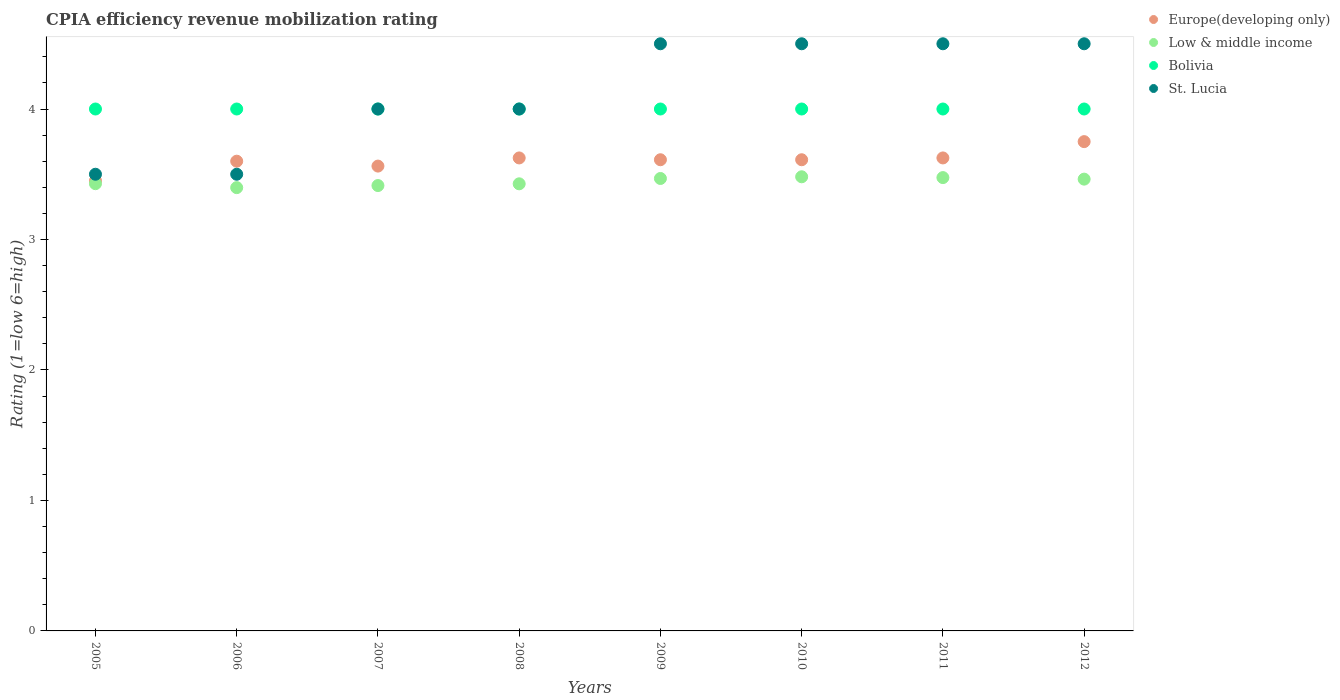Is the number of dotlines equal to the number of legend labels?
Keep it short and to the point. Yes. What is the CPIA rating in Bolivia in 2008?
Give a very brief answer. 4. Across all years, what is the minimum CPIA rating in Low & middle income?
Your response must be concise. 3.4. In which year was the CPIA rating in Bolivia maximum?
Offer a terse response. 2005. What is the total CPIA rating in St. Lucia in the graph?
Offer a terse response. 33. What is the difference between the CPIA rating in Bolivia in 2008 and the CPIA rating in Europe(developing only) in 2010?
Provide a succinct answer. 0.39. What is the average CPIA rating in Low & middle income per year?
Your answer should be very brief. 3.44. In the year 2008, what is the difference between the CPIA rating in Low & middle income and CPIA rating in St. Lucia?
Offer a very short reply. -0.57. What is the ratio of the CPIA rating in St. Lucia in 2006 to that in 2010?
Your answer should be very brief. 0.78. Is the difference between the CPIA rating in Low & middle income in 2006 and 2010 greater than the difference between the CPIA rating in St. Lucia in 2006 and 2010?
Offer a very short reply. Yes. What is the difference between the highest and the second highest CPIA rating in Europe(developing only)?
Provide a short and direct response. 0.12. What is the difference between the highest and the lowest CPIA rating in St. Lucia?
Your response must be concise. 1. In how many years, is the CPIA rating in Low & middle income greater than the average CPIA rating in Low & middle income taken over all years?
Offer a very short reply. 4. Is the sum of the CPIA rating in Europe(developing only) in 2008 and 2012 greater than the maximum CPIA rating in Bolivia across all years?
Keep it short and to the point. Yes. Is it the case that in every year, the sum of the CPIA rating in Bolivia and CPIA rating in Europe(developing only)  is greater than the sum of CPIA rating in Low & middle income and CPIA rating in St. Lucia?
Your answer should be very brief. No. How many dotlines are there?
Offer a very short reply. 4. What is the difference between two consecutive major ticks on the Y-axis?
Ensure brevity in your answer.  1. Does the graph contain any zero values?
Give a very brief answer. No. Does the graph contain grids?
Your response must be concise. No. Where does the legend appear in the graph?
Make the answer very short. Top right. What is the title of the graph?
Offer a very short reply. CPIA efficiency revenue mobilization rating. Does "Burkina Faso" appear as one of the legend labels in the graph?
Your answer should be very brief. No. What is the Rating (1=low 6=high) of Europe(developing only) in 2005?
Your answer should be very brief. 3.45. What is the Rating (1=low 6=high) in Low & middle income in 2005?
Give a very brief answer. 3.43. What is the Rating (1=low 6=high) of St. Lucia in 2005?
Your answer should be very brief. 3.5. What is the Rating (1=low 6=high) in Europe(developing only) in 2006?
Keep it short and to the point. 3.6. What is the Rating (1=low 6=high) in Low & middle income in 2006?
Keep it short and to the point. 3.4. What is the Rating (1=low 6=high) of Europe(developing only) in 2007?
Your answer should be very brief. 3.56. What is the Rating (1=low 6=high) of Low & middle income in 2007?
Give a very brief answer. 3.41. What is the Rating (1=low 6=high) in Europe(developing only) in 2008?
Your response must be concise. 3.62. What is the Rating (1=low 6=high) of Low & middle income in 2008?
Provide a short and direct response. 3.43. What is the Rating (1=low 6=high) in Bolivia in 2008?
Your answer should be compact. 4. What is the Rating (1=low 6=high) in St. Lucia in 2008?
Your answer should be very brief. 4. What is the Rating (1=low 6=high) in Europe(developing only) in 2009?
Provide a short and direct response. 3.61. What is the Rating (1=low 6=high) of Low & middle income in 2009?
Provide a succinct answer. 3.47. What is the Rating (1=low 6=high) in St. Lucia in 2009?
Give a very brief answer. 4.5. What is the Rating (1=low 6=high) in Europe(developing only) in 2010?
Offer a very short reply. 3.61. What is the Rating (1=low 6=high) of Low & middle income in 2010?
Your response must be concise. 3.48. What is the Rating (1=low 6=high) in St. Lucia in 2010?
Your answer should be compact. 4.5. What is the Rating (1=low 6=high) in Europe(developing only) in 2011?
Ensure brevity in your answer.  3.62. What is the Rating (1=low 6=high) of Low & middle income in 2011?
Keep it short and to the point. 3.47. What is the Rating (1=low 6=high) in Bolivia in 2011?
Offer a very short reply. 4. What is the Rating (1=low 6=high) in Europe(developing only) in 2012?
Give a very brief answer. 3.75. What is the Rating (1=low 6=high) in Low & middle income in 2012?
Provide a short and direct response. 3.46. What is the Rating (1=low 6=high) in St. Lucia in 2012?
Ensure brevity in your answer.  4.5. Across all years, what is the maximum Rating (1=low 6=high) in Europe(developing only)?
Keep it short and to the point. 3.75. Across all years, what is the maximum Rating (1=low 6=high) of Low & middle income?
Ensure brevity in your answer.  3.48. Across all years, what is the maximum Rating (1=low 6=high) in St. Lucia?
Your answer should be compact. 4.5. Across all years, what is the minimum Rating (1=low 6=high) in Europe(developing only)?
Offer a very short reply. 3.45. Across all years, what is the minimum Rating (1=low 6=high) in Low & middle income?
Offer a terse response. 3.4. Across all years, what is the minimum Rating (1=low 6=high) of St. Lucia?
Offer a very short reply. 3.5. What is the total Rating (1=low 6=high) in Europe(developing only) in the graph?
Keep it short and to the point. 28.83. What is the total Rating (1=low 6=high) in Low & middle income in the graph?
Keep it short and to the point. 27.55. What is the total Rating (1=low 6=high) in Bolivia in the graph?
Give a very brief answer. 32. What is the total Rating (1=low 6=high) in St. Lucia in the graph?
Provide a short and direct response. 33. What is the difference between the Rating (1=low 6=high) in Low & middle income in 2005 and that in 2006?
Your answer should be very brief. 0.03. What is the difference between the Rating (1=low 6=high) of Europe(developing only) in 2005 and that in 2007?
Ensure brevity in your answer.  -0.11. What is the difference between the Rating (1=low 6=high) of Low & middle income in 2005 and that in 2007?
Your answer should be very brief. 0.01. What is the difference between the Rating (1=low 6=high) in Bolivia in 2005 and that in 2007?
Ensure brevity in your answer.  0. What is the difference between the Rating (1=low 6=high) of Europe(developing only) in 2005 and that in 2008?
Keep it short and to the point. -0.17. What is the difference between the Rating (1=low 6=high) of Europe(developing only) in 2005 and that in 2009?
Provide a short and direct response. -0.16. What is the difference between the Rating (1=low 6=high) in Low & middle income in 2005 and that in 2009?
Your answer should be compact. -0.04. What is the difference between the Rating (1=low 6=high) in Bolivia in 2005 and that in 2009?
Your answer should be very brief. 0. What is the difference between the Rating (1=low 6=high) in Europe(developing only) in 2005 and that in 2010?
Your answer should be very brief. -0.16. What is the difference between the Rating (1=low 6=high) of Low & middle income in 2005 and that in 2010?
Keep it short and to the point. -0.05. What is the difference between the Rating (1=low 6=high) of St. Lucia in 2005 and that in 2010?
Offer a terse response. -1. What is the difference between the Rating (1=low 6=high) of Europe(developing only) in 2005 and that in 2011?
Your answer should be compact. -0.17. What is the difference between the Rating (1=low 6=high) of Low & middle income in 2005 and that in 2011?
Your answer should be very brief. -0.05. What is the difference between the Rating (1=low 6=high) in Bolivia in 2005 and that in 2011?
Your response must be concise. 0. What is the difference between the Rating (1=low 6=high) of Europe(developing only) in 2005 and that in 2012?
Offer a terse response. -0.3. What is the difference between the Rating (1=low 6=high) of Low & middle income in 2005 and that in 2012?
Your response must be concise. -0.03. What is the difference between the Rating (1=low 6=high) of St. Lucia in 2005 and that in 2012?
Give a very brief answer. -1. What is the difference between the Rating (1=low 6=high) of Europe(developing only) in 2006 and that in 2007?
Give a very brief answer. 0.04. What is the difference between the Rating (1=low 6=high) of Low & middle income in 2006 and that in 2007?
Your answer should be very brief. -0.02. What is the difference between the Rating (1=low 6=high) in Bolivia in 2006 and that in 2007?
Offer a terse response. 0. What is the difference between the Rating (1=low 6=high) of Europe(developing only) in 2006 and that in 2008?
Make the answer very short. -0.03. What is the difference between the Rating (1=low 6=high) in Low & middle income in 2006 and that in 2008?
Your answer should be very brief. -0.03. What is the difference between the Rating (1=low 6=high) in Bolivia in 2006 and that in 2008?
Keep it short and to the point. 0. What is the difference between the Rating (1=low 6=high) of St. Lucia in 2006 and that in 2008?
Provide a short and direct response. -0.5. What is the difference between the Rating (1=low 6=high) in Europe(developing only) in 2006 and that in 2009?
Your answer should be very brief. -0.01. What is the difference between the Rating (1=low 6=high) of Low & middle income in 2006 and that in 2009?
Make the answer very short. -0.07. What is the difference between the Rating (1=low 6=high) of St. Lucia in 2006 and that in 2009?
Make the answer very short. -1. What is the difference between the Rating (1=low 6=high) of Europe(developing only) in 2006 and that in 2010?
Your response must be concise. -0.01. What is the difference between the Rating (1=low 6=high) of Low & middle income in 2006 and that in 2010?
Provide a succinct answer. -0.08. What is the difference between the Rating (1=low 6=high) of Europe(developing only) in 2006 and that in 2011?
Provide a short and direct response. -0.03. What is the difference between the Rating (1=low 6=high) in Low & middle income in 2006 and that in 2011?
Provide a short and direct response. -0.08. What is the difference between the Rating (1=low 6=high) in St. Lucia in 2006 and that in 2011?
Ensure brevity in your answer.  -1. What is the difference between the Rating (1=low 6=high) of Europe(developing only) in 2006 and that in 2012?
Your response must be concise. -0.15. What is the difference between the Rating (1=low 6=high) in Low & middle income in 2006 and that in 2012?
Your response must be concise. -0.07. What is the difference between the Rating (1=low 6=high) in Bolivia in 2006 and that in 2012?
Your answer should be compact. 0. What is the difference between the Rating (1=low 6=high) in St. Lucia in 2006 and that in 2012?
Your answer should be compact. -1. What is the difference between the Rating (1=low 6=high) of Europe(developing only) in 2007 and that in 2008?
Provide a short and direct response. -0.06. What is the difference between the Rating (1=low 6=high) of Low & middle income in 2007 and that in 2008?
Provide a succinct answer. -0.01. What is the difference between the Rating (1=low 6=high) in Bolivia in 2007 and that in 2008?
Give a very brief answer. 0. What is the difference between the Rating (1=low 6=high) of Europe(developing only) in 2007 and that in 2009?
Provide a succinct answer. -0.05. What is the difference between the Rating (1=low 6=high) of Low & middle income in 2007 and that in 2009?
Offer a terse response. -0.05. What is the difference between the Rating (1=low 6=high) in Bolivia in 2007 and that in 2009?
Offer a very short reply. 0. What is the difference between the Rating (1=low 6=high) of St. Lucia in 2007 and that in 2009?
Give a very brief answer. -0.5. What is the difference between the Rating (1=low 6=high) of Europe(developing only) in 2007 and that in 2010?
Keep it short and to the point. -0.05. What is the difference between the Rating (1=low 6=high) in Low & middle income in 2007 and that in 2010?
Your answer should be very brief. -0.07. What is the difference between the Rating (1=low 6=high) in St. Lucia in 2007 and that in 2010?
Make the answer very short. -0.5. What is the difference between the Rating (1=low 6=high) in Europe(developing only) in 2007 and that in 2011?
Ensure brevity in your answer.  -0.06. What is the difference between the Rating (1=low 6=high) in Low & middle income in 2007 and that in 2011?
Your answer should be compact. -0.06. What is the difference between the Rating (1=low 6=high) in Bolivia in 2007 and that in 2011?
Your answer should be compact. 0. What is the difference between the Rating (1=low 6=high) of St. Lucia in 2007 and that in 2011?
Make the answer very short. -0.5. What is the difference between the Rating (1=low 6=high) of Europe(developing only) in 2007 and that in 2012?
Provide a succinct answer. -0.19. What is the difference between the Rating (1=low 6=high) in Low & middle income in 2007 and that in 2012?
Make the answer very short. -0.05. What is the difference between the Rating (1=low 6=high) of St. Lucia in 2007 and that in 2012?
Your response must be concise. -0.5. What is the difference between the Rating (1=low 6=high) of Europe(developing only) in 2008 and that in 2009?
Make the answer very short. 0.01. What is the difference between the Rating (1=low 6=high) in Low & middle income in 2008 and that in 2009?
Offer a very short reply. -0.04. What is the difference between the Rating (1=low 6=high) in Bolivia in 2008 and that in 2009?
Offer a very short reply. 0. What is the difference between the Rating (1=low 6=high) in Europe(developing only) in 2008 and that in 2010?
Give a very brief answer. 0.01. What is the difference between the Rating (1=low 6=high) in Low & middle income in 2008 and that in 2010?
Make the answer very short. -0.05. What is the difference between the Rating (1=low 6=high) in St. Lucia in 2008 and that in 2010?
Your response must be concise. -0.5. What is the difference between the Rating (1=low 6=high) in Low & middle income in 2008 and that in 2011?
Your answer should be compact. -0.05. What is the difference between the Rating (1=low 6=high) in Bolivia in 2008 and that in 2011?
Offer a terse response. 0. What is the difference between the Rating (1=low 6=high) in St. Lucia in 2008 and that in 2011?
Offer a terse response. -0.5. What is the difference between the Rating (1=low 6=high) in Europe(developing only) in 2008 and that in 2012?
Your answer should be very brief. -0.12. What is the difference between the Rating (1=low 6=high) in Low & middle income in 2008 and that in 2012?
Keep it short and to the point. -0.04. What is the difference between the Rating (1=low 6=high) of Low & middle income in 2009 and that in 2010?
Give a very brief answer. -0.01. What is the difference between the Rating (1=low 6=high) in Europe(developing only) in 2009 and that in 2011?
Provide a succinct answer. -0.01. What is the difference between the Rating (1=low 6=high) in Low & middle income in 2009 and that in 2011?
Provide a short and direct response. -0.01. What is the difference between the Rating (1=low 6=high) of St. Lucia in 2009 and that in 2011?
Ensure brevity in your answer.  0. What is the difference between the Rating (1=low 6=high) in Europe(developing only) in 2009 and that in 2012?
Your response must be concise. -0.14. What is the difference between the Rating (1=low 6=high) of Low & middle income in 2009 and that in 2012?
Keep it short and to the point. 0.01. What is the difference between the Rating (1=low 6=high) in Bolivia in 2009 and that in 2012?
Keep it short and to the point. 0. What is the difference between the Rating (1=low 6=high) in Europe(developing only) in 2010 and that in 2011?
Keep it short and to the point. -0.01. What is the difference between the Rating (1=low 6=high) in Low & middle income in 2010 and that in 2011?
Make the answer very short. 0.01. What is the difference between the Rating (1=low 6=high) in Bolivia in 2010 and that in 2011?
Your answer should be compact. 0. What is the difference between the Rating (1=low 6=high) of St. Lucia in 2010 and that in 2011?
Your response must be concise. 0. What is the difference between the Rating (1=low 6=high) of Europe(developing only) in 2010 and that in 2012?
Provide a short and direct response. -0.14. What is the difference between the Rating (1=low 6=high) in Low & middle income in 2010 and that in 2012?
Provide a short and direct response. 0.02. What is the difference between the Rating (1=low 6=high) of St. Lucia in 2010 and that in 2012?
Ensure brevity in your answer.  0. What is the difference between the Rating (1=low 6=high) in Europe(developing only) in 2011 and that in 2012?
Ensure brevity in your answer.  -0.12. What is the difference between the Rating (1=low 6=high) of Low & middle income in 2011 and that in 2012?
Your answer should be compact. 0.01. What is the difference between the Rating (1=low 6=high) of Bolivia in 2011 and that in 2012?
Keep it short and to the point. 0. What is the difference between the Rating (1=low 6=high) of St. Lucia in 2011 and that in 2012?
Offer a very short reply. 0. What is the difference between the Rating (1=low 6=high) in Europe(developing only) in 2005 and the Rating (1=low 6=high) in Low & middle income in 2006?
Your answer should be very brief. 0.05. What is the difference between the Rating (1=low 6=high) in Europe(developing only) in 2005 and the Rating (1=low 6=high) in Bolivia in 2006?
Provide a succinct answer. -0.55. What is the difference between the Rating (1=low 6=high) of Low & middle income in 2005 and the Rating (1=low 6=high) of Bolivia in 2006?
Keep it short and to the point. -0.57. What is the difference between the Rating (1=low 6=high) of Low & middle income in 2005 and the Rating (1=low 6=high) of St. Lucia in 2006?
Your answer should be compact. -0.07. What is the difference between the Rating (1=low 6=high) of Europe(developing only) in 2005 and the Rating (1=low 6=high) of Low & middle income in 2007?
Ensure brevity in your answer.  0.04. What is the difference between the Rating (1=low 6=high) in Europe(developing only) in 2005 and the Rating (1=low 6=high) in Bolivia in 2007?
Your answer should be very brief. -0.55. What is the difference between the Rating (1=low 6=high) in Europe(developing only) in 2005 and the Rating (1=low 6=high) in St. Lucia in 2007?
Your answer should be very brief. -0.55. What is the difference between the Rating (1=low 6=high) of Low & middle income in 2005 and the Rating (1=low 6=high) of Bolivia in 2007?
Give a very brief answer. -0.57. What is the difference between the Rating (1=low 6=high) in Low & middle income in 2005 and the Rating (1=low 6=high) in St. Lucia in 2007?
Offer a terse response. -0.57. What is the difference between the Rating (1=low 6=high) in Europe(developing only) in 2005 and the Rating (1=low 6=high) in Low & middle income in 2008?
Keep it short and to the point. 0.02. What is the difference between the Rating (1=low 6=high) of Europe(developing only) in 2005 and the Rating (1=low 6=high) of Bolivia in 2008?
Make the answer very short. -0.55. What is the difference between the Rating (1=low 6=high) in Europe(developing only) in 2005 and the Rating (1=low 6=high) in St. Lucia in 2008?
Give a very brief answer. -0.55. What is the difference between the Rating (1=low 6=high) of Low & middle income in 2005 and the Rating (1=low 6=high) of Bolivia in 2008?
Ensure brevity in your answer.  -0.57. What is the difference between the Rating (1=low 6=high) of Low & middle income in 2005 and the Rating (1=low 6=high) of St. Lucia in 2008?
Keep it short and to the point. -0.57. What is the difference between the Rating (1=low 6=high) in Bolivia in 2005 and the Rating (1=low 6=high) in St. Lucia in 2008?
Your answer should be very brief. 0. What is the difference between the Rating (1=low 6=high) of Europe(developing only) in 2005 and the Rating (1=low 6=high) of Low & middle income in 2009?
Give a very brief answer. -0.02. What is the difference between the Rating (1=low 6=high) of Europe(developing only) in 2005 and the Rating (1=low 6=high) of Bolivia in 2009?
Provide a succinct answer. -0.55. What is the difference between the Rating (1=low 6=high) of Europe(developing only) in 2005 and the Rating (1=low 6=high) of St. Lucia in 2009?
Provide a short and direct response. -1.05. What is the difference between the Rating (1=low 6=high) in Low & middle income in 2005 and the Rating (1=low 6=high) in Bolivia in 2009?
Offer a very short reply. -0.57. What is the difference between the Rating (1=low 6=high) of Low & middle income in 2005 and the Rating (1=low 6=high) of St. Lucia in 2009?
Give a very brief answer. -1.07. What is the difference between the Rating (1=low 6=high) in Bolivia in 2005 and the Rating (1=low 6=high) in St. Lucia in 2009?
Offer a terse response. -0.5. What is the difference between the Rating (1=low 6=high) in Europe(developing only) in 2005 and the Rating (1=low 6=high) in Low & middle income in 2010?
Make the answer very short. -0.03. What is the difference between the Rating (1=low 6=high) in Europe(developing only) in 2005 and the Rating (1=low 6=high) in Bolivia in 2010?
Provide a short and direct response. -0.55. What is the difference between the Rating (1=low 6=high) in Europe(developing only) in 2005 and the Rating (1=low 6=high) in St. Lucia in 2010?
Provide a succinct answer. -1.05. What is the difference between the Rating (1=low 6=high) in Low & middle income in 2005 and the Rating (1=low 6=high) in Bolivia in 2010?
Give a very brief answer. -0.57. What is the difference between the Rating (1=low 6=high) in Low & middle income in 2005 and the Rating (1=low 6=high) in St. Lucia in 2010?
Keep it short and to the point. -1.07. What is the difference between the Rating (1=low 6=high) of Europe(developing only) in 2005 and the Rating (1=low 6=high) of Low & middle income in 2011?
Offer a terse response. -0.02. What is the difference between the Rating (1=low 6=high) in Europe(developing only) in 2005 and the Rating (1=low 6=high) in Bolivia in 2011?
Offer a terse response. -0.55. What is the difference between the Rating (1=low 6=high) in Europe(developing only) in 2005 and the Rating (1=low 6=high) in St. Lucia in 2011?
Provide a short and direct response. -1.05. What is the difference between the Rating (1=low 6=high) of Low & middle income in 2005 and the Rating (1=low 6=high) of Bolivia in 2011?
Provide a succinct answer. -0.57. What is the difference between the Rating (1=low 6=high) in Low & middle income in 2005 and the Rating (1=low 6=high) in St. Lucia in 2011?
Provide a short and direct response. -1.07. What is the difference between the Rating (1=low 6=high) of Bolivia in 2005 and the Rating (1=low 6=high) of St. Lucia in 2011?
Give a very brief answer. -0.5. What is the difference between the Rating (1=low 6=high) in Europe(developing only) in 2005 and the Rating (1=low 6=high) in Low & middle income in 2012?
Provide a short and direct response. -0.01. What is the difference between the Rating (1=low 6=high) in Europe(developing only) in 2005 and the Rating (1=low 6=high) in Bolivia in 2012?
Your answer should be compact. -0.55. What is the difference between the Rating (1=low 6=high) of Europe(developing only) in 2005 and the Rating (1=low 6=high) of St. Lucia in 2012?
Your response must be concise. -1.05. What is the difference between the Rating (1=low 6=high) in Low & middle income in 2005 and the Rating (1=low 6=high) in Bolivia in 2012?
Make the answer very short. -0.57. What is the difference between the Rating (1=low 6=high) of Low & middle income in 2005 and the Rating (1=low 6=high) of St. Lucia in 2012?
Keep it short and to the point. -1.07. What is the difference between the Rating (1=low 6=high) in Bolivia in 2005 and the Rating (1=low 6=high) in St. Lucia in 2012?
Keep it short and to the point. -0.5. What is the difference between the Rating (1=low 6=high) of Europe(developing only) in 2006 and the Rating (1=low 6=high) of Low & middle income in 2007?
Ensure brevity in your answer.  0.19. What is the difference between the Rating (1=low 6=high) in Europe(developing only) in 2006 and the Rating (1=low 6=high) in Bolivia in 2007?
Offer a terse response. -0.4. What is the difference between the Rating (1=low 6=high) of Europe(developing only) in 2006 and the Rating (1=low 6=high) of St. Lucia in 2007?
Your answer should be very brief. -0.4. What is the difference between the Rating (1=low 6=high) in Low & middle income in 2006 and the Rating (1=low 6=high) in Bolivia in 2007?
Make the answer very short. -0.6. What is the difference between the Rating (1=low 6=high) in Low & middle income in 2006 and the Rating (1=low 6=high) in St. Lucia in 2007?
Provide a succinct answer. -0.6. What is the difference between the Rating (1=low 6=high) of Europe(developing only) in 2006 and the Rating (1=low 6=high) of Low & middle income in 2008?
Your answer should be compact. 0.17. What is the difference between the Rating (1=low 6=high) in Europe(developing only) in 2006 and the Rating (1=low 6=high) in Bolivia in 2008?
Make the answer very short. -0.4. What is the difference between the Rating (1=low 6=high) in Europe(developing only) in 2006 and the Rating (1=low 6=high) in St. Lucia in 2008?
Your answer should be compact. -0.4. What is the difference between the Rating (1=low 6=high) of Low & middle income in 2006 and the Rating (1=low 6=high) of Bolivia in 2008?
Your response must be concise. -0.6. What is the difference between the Rating (1=low 6=high) of Low & middle income in 2006 and the Rating (1=low 6=high) of St. Lucia in 2008?
Make the answer very short. -0.6. What is the difference between the Rating (1=low 6=high) in Bolivia in 2006 and the Rating (1=low 6=high) in St. Lucia in 2008?
Your answer should be very brief. 0. What is the difference between the Rating (1=low 6=high) of Europe(developing only) in 2006 and the Rating (1=low 6=high) of Low & middle income in 2009?
Offer a very short reply. 0.13. What is the difference between the Rating (1=low 6=high) of Europe(developing only) in 2006 and the Rating (1=low 6=high) of Bolivia in 2009?
Keep it short and to the point. -0.4. What is the difference between the Rating (1=low 6=high) of Europe(developing only) in 2006 and the Rating (1=low 6=high) of St. Lucia in 2009?
Your response must be concise. -0.9. What is the difference between the Rating (1=low 6=high) of Low & middle income in 2006 and the Rating (1=low 6=high) of Bolivia in 2009?
Offer a very short reply. -0.6. What is the difference between the Rating (1=low 6=high) of Low & middle income in 2006 and the Rating (1=low 6=high) of St. Lucia in 2009?
Offer a very short reply. -1.1. What is the difference between the Rating (1=low 6=high) of Bolivia in 2006 and the Rating (1=low 6=high) of St. Lucia in 2009?
Give a very brief answer. -0.5. What is the difference between the Rating (1=low 6=high) in Europe(developing only) in 2006 and the Rating (1=low 6=high) in Low & middle income in 2010?
Ensure brevity in your answer.  0.12. What is the difference between the Rating (1=low 6=high) of Europe(developing only) in 2006 and the Rating (1=low 6=high) of Bolivia in 2010?
Offer a very short reply. -0.4. What is the difference between the Rating (1=low 6=high) in Europe(developing only) in 2006 and the Rating (1=low 6=high) in St. Lucia in 2010?
Provide a succinct answer. -0.9. What is the difference between the Rating (1=low 6=high) of Low & middle income in 2006 and the Rating (1=low 6=high) of Bolivia in 2010?
Your answer should be very brief. -0.6. What is the difference between the Rating (1=low 6=high) of Low & middle income in 2006 and the Rating (1=low 6=high) of St. Lucia in 2010?
Offer a very short reply. -1.1. What is the difference between the Rating (1=low 6=high) in Europe(developing only) in 2006 and the Rating (1=low 6=high) in Low & middle income in 2011?
Your answer should be very brief. 0.13. What is the difference between the Rating (1=low 6=high) of Europe(developing only) in 2006 and the Rating (1=low 6=high) of Bolivia in 2011?
Your response must be concise. -0.4. What is the difference between the Rating (1=low 6=high) of Europe(developing only) in 2006 and the Rating (1=low 6=high) of St. Lucia in 2011?
Your answer should be very brief. -0.9. What is the difference between the Rating (1=low 6=high) of Low & middle income in 2006 and the Rating (1=low 6=high) of Bolivia in 2011?
Provide a short and direct response. -0.6. What is the difference between the Rating (1=low 6=high) in Low & middle income in 2006 and the Rating (1=low 6=high) in St. Lucia in 2011?
Provide a short and direct response. -1.1. What is the difference between the Rating (1=low 6=high) of Europe(developing only) in 2006 and the Rating (1=low 6=high) of Low & middle income in 2012?
Your answer should be compact. 0.14. What is the difference between the Rating (1=low 6=high) in Low & middle income in 2006 and the Rating (1=low 6=high) in Bolivia in 2012?
Your answer should be very brief. -0.6. What is the difference between the Rating (1=low 6=high) of Low & middle income in 2006 and the Rating (1=low 6=high) of St. Lucia in 2012?
Your answer should be very brief. -1.1. What is the difference between the Rating (1=low 6=high) in Bolivia in 2006 and the Rating (1=low 6=high) in St. Lucia in 2012?
Give a very brief answer. -0.5. What is the difference between the Rating (1=low 6=high) in Europe(developing only) in 2007 and the Rating (1=low 6=high) in Low & middle income in 2008?
Offer a very short reply. 0.14. What is the difference between the Rating (1=low 6=high) of Europe(developing only) in 2007 and the Rating (1=low 6=high) of Bolivia in 2008?
Ensure brevity in your answer.  -0.44. What is the difference between the Rating (1=low 6=high) in Europe(developing only) in 2007 and the Rating (1=low 6=high) in St. Lucia in 2008?
Provide a succinct answer. -0.44. What is the difference between the Rating (1=low 6=high) in Low & middle income in 2007 and the Rating (1=low 6=high) in Bolivia in 2008?
Offer a terse response. -0.59. What is the difference between the Rating (1=low 6=high) of Low & middle income in 2007 and the Rating (1=low 6=high) of St. Lucia in 2008?
Give a very brief answer. -0.59. What is the difference between the Rating (1=low 6=high) in Bolivia in 2007 and the Rating (1=low 6=high) in St. Lucia in 2008?
Offer a very short reply. 0. What is the difference between the Rating (1=low 6=high) of Europe(developing only) in 2007 and the Rating (1=low 6=high) of Low & middle income in 2009?
Provide a short and direct response. 0.1. What is the difference between the Rating (1=low 6=high) of Europe(developing only) in 2007 and the Rating (1=low 6=high) of Bolivia in 2009?
Make the answer very short. -0.44. What is the difference between the Rating (1=low 6=high) of Europe(developing only) in 2007 and the Rating (1=low 6=high) of St. Lucia in 2009?
Give a very brief answer. -0.94. What is the difference between the Rating (1=low 6=high) of Low & middle income in 2007 and the Rating (1=low 6=high) of Bolivia in 2009?
Provide a short and direct response. -0.59. What is the difference between the Rating (1=low 6=high) of Low & middle income in 2007 and the Rating (1=low 6=high) of St. Lucia in 2009?
Provide a succinct answer. -1.09. What is the difference between the Rating (1=low 6=high) in Bolivia in 2007 and the Rating (1=low 6=high) in St. Lucia in 2009?
Give a very brief answer. -0.5. What is the difference between the Rating (1=low 6=high) of Europe(developing only) in 2007 and the Rating (1=low 6=high) of Low & middle income in 2010?
Ensure brevity in your answer.  0.08. What is the difference between the Rating (1=low 6=high) in Europe(developing only) in 2007 and the Rating (1=low 6=high) in Bolivia in 2010?
Offer a terse response. -0.44. What is the difference between the Rating (1=low 6=high) in Europe(developing only) in 2007 and the Rating (1=low 6=high) in St. Lucia in 2010?
Your answer should be compact. -0.94. What is the difference between the Rating (1=low 6=high) of Low & middle income in 2007 and the Rating (1=low 6=high) of Bolivia in 2010?
Your response must be concise. -0.59. What is the difference between the Rating (1=low 6=high) of Low & middle income in 2007 and the Rating (1=low 6=high) of St. Lucia in 2010?
Your answer should be compact. -1.09. What is the difference between the Rating (1=low 6=high) of Europe(developing only) in 2007 and the Rating (1=low 6=high) of Low & middle income in 2011?
Your answer should be compact. 0.09. What is the difference between the Rating (1=low 6=high) of Europe(developing only) in 2007 and the Rating (1=low 6=high) of Bolivia in 2011?
Provide a succinct answer. -0.44. What is the difference between the Rating (1=low 6=high) of Europe(developing only) in 2007 and the Rating (1=low 6=high) of St. Lucia in 2011?
Provide a short and direct response. -0.94. What is the difference between the Rating (1=low 6=high) in Low & middle income in 2007 and the Rating (1=low 6=high) in Bolivia in 2011?
Ensure brevity in your answer.  -0.59. What is the difference between the Rating (1=low 6=high) in Low & middle income in 2007 and the Rating (1=low 6=high) in St. Lucia in 2011?
Keep it short and to the point. -1.09. What is the difference between the Rating (1=low 6=high) of Europe(developing only) in 2007 and the Rating (1=low 6=high) of Low & middle income in 2012?
Keep it short and to the point. 0.1. What is the difference between the Rating (1=low 6=high) of Europe(developing only) in 2007 and the Rating (1=low 6=high) of Bolivia in 2012?
Give a very brief answer. -0.44. What is the difference between the Rating (1=low 6=high) of Europe(developing only) in 2007 and the Rating (1=low 6=high) of St. Lucia in 2012?
Offer a very short reply. -0.94. What is the difference between the Rating (1=low 6=high) of Low & middle income in 2007 and the Rating (1=low 6=high) of Bolivia in 2012?
Your response must be concise. -0.59. What is the difference between the Rating (1=low 6=high) in Low & middle income in 2007 and the Rating (1=low 6=high) in St. Lucia in 2012?
Your answer should be compact. -1.09. What is the difference between the Rating (1=low 6=high) of Bolivia in 2007 and the Rating (1=low 6=high) of St. Lucia in 2012?
Your answer should be very brief. -0.5. What is the difference between the Rating (1=low 6=high) in Europe(developing only) in 2008 and the Rating (1=low 6=high) in Low & middle income in 2009?
Your response must be concise. 0.16. What is the difference between the Rating (1=low 6=high) in Europe(developing only) in 2008 and the Rating (1=low 6=high) in Bolivia in 2009?
Provide a succinct answer. -0.38. What is the difference between the Rating (1=low 6=high) in Europe(developing only) in 2008 and the Rating (1=low 6=high) in St. Lucia in 2009?
Ensure brevity in your answer.  -0.88. What is the difference between the Rating (1=low 6=high) in Low & middle income in 2008 and the Rating (1=low 6=high) in Bolivia in 2009?
Your response must be concise. -0.57. What is the difference between the Rating (1=low 6=high) in Low & middle income in 2008 and the Rating (1=low 6=high) in St. Lucia in 2009?
Give a very brief answer. -1.07. What is the difference between the Rating (1=low 6=high) in Bolivia in 2008 and the Rating (1=low 6=high) in St. Lucia in 2009?
Ensure brevity in your answer.  -0.5. What is the difference between the Rating (1=low 6=high) of Europe(developing only) in 2008 and the Rating (1=low 6=high) of Low & middle income in 2010?
Your response must be concise. 0.14. What is the difference between the Rating (1=low 6=high) of Europe(developing only) in 2008 and the Rating (1=low 6=high) of Bolivia in 2010?
Provide a succinct answer. -0.38. What is the difference between the Rating (1=low 6=high) in Europe(developing only) in 2008 and the Rating (1=low 6=high) in St. Lucia in 2010?
Your answer should be very brief. -0.88. What is the difference between the Rating (1=low 6=high) of Low & middle income in 2008 and the Rating (1=low 6=high) of Bolivia in 2010?
Provide a short and direct response. -0.57. What is the difference between the Rating (1=low 6=high) of Low & middle income in 2008 and the Rating (1=low 6=high) of St. Lucia in 2010?
Your response must be concise. -1.07. What is the difference between the Rating (1=low 6=high) in Europe(developing only) in 2008 and the Rating (1=low 6=high) in Low & middle income in 2011?
Offer a terse response. 0.15. What is the difference between the Rating (1=low 6=high) in Europe(developing only) in 2008 and the Rating (1=low 6=high) in Bolivia in 2011?
Provide a short and direct response. -0.38. What is the difference between the Rating (1=low 6=high) of Europe(developing only) in 2008 and the Rating (1=low 6=high) of St. Lucia in 2011?
Offer a very short reply. -0.88. What is the difference between the Rating (1=low 6=high) in Low & middle income in 2008 and the Rating (1=low 6=high) in Bolivia in 2011?
Offer a very short reply. -0.57. What is the difference between the Rating (1=low 6=high) of Low & middle income in 2008 and the Rating (1=low 6=high) of St. Lucia in 2011?
Ensure brevity in your answer.  -1.07. What is the difference between the Rating (1=low 6=high) in Bolivia in 2008 and the Rating (1=low 6=high) in St. Lucia in 2011?
Ensure brevity in your answer.  -0.5. What is the difference between the Rating (1=low 6=high) in Europe(developing only) in 2008 and the Rating (1=low 6=high) in Low & middle income in 2012?
Give a very brief answer. 0.16. What is the difference between the Rating (1=low 6=high) of Europe(developing only) in 2008 and the Rating (1=low 6=high) of Bolivia in 2012?
Ensure brevity in your answer.  -0.38. What is the difference between the Rating (1=low 6=high) of Europe(developing only) in 2008 and the Rating (1=low 6=high) of St. Lucia in 2012?
Provide a short and direct response. -0.88. What is the difference between the Rating (1=low 6=high) in Low & middle income in 2008 and the Rating (1=low 6=high) in Bolivia in 2012?
Your answer should be compact. -0.57. What is the difference between the Rating (1=low 6=high) of Low & middle income in 2008 and the Rating (1=low 6=high) of St. Lucia in 2012?
Provide a short and direct response. -1.07. What is the difference between the Rating (1=low 6=high) in Bolivia in 2008 and the Rating (1=low 6=high) in St. Lucia in 2012?
Your answer should be very brief. -0.5. What is the difference between the Rating (1=low 6=high) of Europe(developing only) in 2009 and the Rating (1=low 6=high) of Low & middle income in 2010?
Offer a terse response. 0.13. What is the difference between the Rating (1=low 6=high) of Europe(developing only) in 2009 and the Rating (1=low 6=high) of Bolivia in 2010?
Ensure brevity in your answer.  -0.39. What is the difference between the Rating (1=low 6=high) of Europe(developing only) in 2009 and the Rating (1=low 6=high) of St. Lucia in 2010?
Your response must be concise. -0.89. What is the difference between the Rating (1=low 6=high) in Low & middle income in 2009 and the Rating (1=low 6=high) in Bolivia in 2010?
Your answer should be compact. -0.53. What is the difference between the Rating (1=low 6=high) of Low & middle income in 2009 and the Rating (1=low 6=high) of St. Lucia in 2010?
Keep it short and to the point. -1.03. What is the difference between the Rating (1=low 6=high) in Bolivia in 2009 and the Rating (1=low 6=high) in St. Lucia in 2010?
Your response must be concise. -0.5. What is the difference between the Rating (1=low 6=high) in Europe(developing only) in 2009 and the Rating (1=low 6=high) in Low & middle income in 2011?
Ensure brevity in your answer.  0.14. What is the difference between the Rating (1=low 6=high) of Europe(developing only) in 2009 and the Rating (1=low 6=high) of Bolivia in 2011?
Provide a short and direct response. -0.39. What is the difference between the Rating (1=low 6=high) in Europe(developing only) in 2009 and the Rating (1=low 6=high) in St. Lucia in 2011?
Make the answer very short. -0.89. What is the difference between the Rating (1=low 6=high) in Low & middle income in 2009 and the Rating (1=low 6=high) in Bolivia in 2011?
Offer a terse response. -0.53. What is the difference between the Rating (1=low 6=high) of Low & middle income in 2009 and the Rating (1=low 6=high) of St. Lucia in 2011?
Ensure brevity in your answer.  -1.03. What is the difference between the Rating (1=low 6=high) in Bolivia in 2009 and the Rating (1=low 6=high) in St. Lucia in 2011?
Make the answer very short. -0.5. What is the difference between the Rating (1=low 6=high) of Europe(developing only) in 2009 and the Rating (1=low 6=high) of Low & middle income in 2012?
Ensure brevity in your answer.  0.15. What is the difference between the Rating (1=low 6=high) in Europe(developing only) in 2009 and the Rating (1=low 6=high) in Bolivia in 2012?
Offer a terse response. -0.39. What is the difference between the Rating (1=low 6=high) of Europe(developing only) in 2009 and the Rating (1=low 6=high) of St. Lucia in 2012?
Provide a succinct answer. -0.89. What is the difference between the Rating (1=low 6=high) in Low & middle income in 2009 and the Rating (1=low 6=high) in Bolivia in 2012?
Provide a short and direct response. -0.53. What is the difference between the Rating (1=low 6=high) in Low & middle income in 2009 and the Rating (1=low 6=high) in St. Lucia in 2012?
Make the answer very short. -1.03. What is the difference between the Rating (1=low 6=high) in Bolivia in 2009 and the Rating (1=low 6=high) in St. Lucia in 2012?
Offer a terse response. -0.5. What is the difference between the Rating (1=low 6=high) of Europe(developing only) in 2010 and the Rating (1=low 6=high) of Low & middle income in 2011?
Your answer should be compact. 0.14. What is the difference between the Rating (1=low 6=high) in Europe(developing only) in 2010 and the Rating (1=low 6=high) in Bolivia in 2011?
Your response must be concise. -0.39. What is the difference between the Rating (1=low 6=high) in Europe(developing only) in 2010 and the Rating (1=low 6=high) in St. Lucia in 2011?
Your answer should be compact. -0.89. What is the difference between the Rating (1=low 6=high) in Low & middle income in 2010 and the Rating (1=low 6=high) in Bolivia in 2011?
Make the answer very short. -0.52. What is the difference between the Rating (1=low 6=high) of Low & middle income in 2010 and the Rating (1=low 6=high) of St. Lucia in 2011?
Keep it short and to the point. -1.02. What is the difference between the Rating (1=low 6=high) in Europe(developing only) in 2010 and the Rating (1=low 6=high) in Low & middle income in 2012?
Ensure brevity in your answer.  0.15. What is the difference between the Rating (1=low 6=high) in Europe(developing only) in 2010 and the Rating (1=low 6=high) in Bolivia in 2012?
Offer a terse response. -0.39. What is the difference between the Rating (1=low 6=high) of Europe(developing only) in 2010 and the Rating (1=low 6=high) of St. Lucia in 2012?
Give a very brief answer. -0.89. What is the difference between the Rating (1=low 6=high) of Low & middle income in 2010 and the Rating (1=low 6=high) of Bolivia in 2012?
Your response must be concise. -0.52. What is the difference between the Rating (1=low 6=high) of Low & middle income in 2010 and the Rating (1=low 6=high) of St. Lucia in 2012?
Ensure brevity in your answer.  -1.02. What is the difference between the Rating (1=low 6=high) of Bolivia in 2010 and the Rating (1=low 6=high) of St. Lucia in 2012?
Keep it short and to the point. -0.5. What is the difference between the Rating (1=low 6=high) of Europe(developing only) in 2011 and the Rating (1=low 6=high) of Low & middle income in 2012?
Make the answer very short. 0.16. What is the difference between the Rating (1=low 6=high) in Europe(developing only) in 2011 and the Rating (1=low 6=high) in Bolivia in 2012?
Offer a terse response. -0.38. What is the difference between the Rating (1=low 6=high) of Europe(developing only) in 2011 and the Rating (1=low 6=high) of St. Lucia in 2012?
Give a very brief answer. -0.88. What is the difference between the Rating (1=low 6=high) of Low & middle income in 2011 and the Rating (1=low 6=high) of Bolivia in 2012?
Make the answer very short. -0.53. What is the difference between the Rating (1=low 6=high) of Low & middle income in 2011 and the Rating (1=low 6=high) of St. Lucia in 2012?
Ensure brevity in your answer.  -1.03. What is the difference between the Rating (1=low 6=high) of Bolivia in 2011 and the Rating (1=low 6=high) of St. Lucia in 2012?
Your response must be concise. -0.5. What is the average Rating (1=low 6=high) in Europe(developing only) per year?
Provide a short and direct response. 3.6. What is the average Rating (1=low 6=high) in Low & middle income per year?
Your answer should be compact. 3.44. What is the average Rating (1=low 6=high) of St. Lucia per year?
Offer a terse response. 4.12. In the year 2005, what is the difference between the Rating (1=low 6=high) in Europe(developing only) and Rating (1=low 6=high) in Low & middle income?
Provide a succinct answer. 0.02. In the year 2005, what is the difference between the Rating (1=low 6=high) in Europe(developing only) and Rating (1=low 6=high) in Bolivia?
Make the answer very short. -0.55. In the year 2005, what is the difference between the Rating (1=low 6=high) in Europe(developing only) and Rating (1=low 6=high) in St. Lucia?
Offer a terse response. -0.05. In the year 2005, what is the difference between the Rating (1=low 6=high) in Low & middle income and Rating (1=low 6=high) in Bolivia?
Give a very brief answer. -0.57. In the year 2005, what is the difference between the Rating (1=low 6=high) of Low & middle income and Rating (1=low 6=high) of St. Lucia?
Your response must be concise. -0.07. In the year 2005, what is the difference between the Rating (1=low 6=high) of Bolivia and Rating (1=low 6=high) of St. Lucia?
Ensure brevity in your answer.  0.5. In the year 2006, what is the difference between the Rating (1=low 6=high) in Europe(developing only) and Rating (1=low 6=high) in Low & middle income?
Your answer should be very brief. 0.2. In the year 2006, what is the difference between the Rating (1=low 6=high) in Low & middle income and Rating (1=low 6=high) in Bolivia?
Make the answer very short. -0.6. In the year 2006, what is the difference between the Rating (1=low 6=high) in Low & middle income and Rating (1=low 6=high) in St. Lucia?
Give a very brief answer. -0.1. In the year 2006, what is the difference between the Rating (1=low 6=high) of Bolivia and Rating (1=low 6=high) of St. Lucia?
Make the answer very short. 0.5. In the year 2007, what is the difference between the Rating (1=low 6=high) in Europe(developing only) and Rating (1=low 6=high) in Low & middle income?
Your response must be concise. 0.15. In the year 2007, what is the difference between the Rating (1=low 6=high) of Europe(developing only) and Rating (1=low 6=high) of Bolivia?
Your response must be concise. -0.44. In the year 2007, what is the difference between the Rating (1=low 6=high) of Europe(developing only) and Rating (1=low 6=high) of St. Lucia?
Provide a short and direct response. -0.44. In the year 2007, what is the difference between the Rating (1=low 6=high) in Low & middle income and Rating (1=low 6=high) in Bolivia?
Keep it short and to the point. -0.59. In the year 2007, what is the difference between the Rating (1=low 6=high) in Low & middle income and Rating (1=low 6=high) in St. Lucia?
Your response must be concise. -0.59. In the year 2007, what is the difference between the Rating (1=low 6=high) in Bolivia and Rating (1=low 6=high) in St. Lucia?
Offer a very short reply. 0. In the year 2008, what is the difference between the Rating (1=low 6=high) in Europe(developing only) and Rating (1=low 6=high) in Low & middle income?
Your answer should be very brief. 0.2. In the year 2008, what is the difference between the Rating (1=low 6=high) of Europe(developing only) and Rating (1=low 6=high) of Bolivia?
Your answer should be very brief. -0.38. In the year 2008, what is the difference between the Rating (1=low 6=high) of Europe(developing only) and Rating (1=low 6=high) of St. Lucia?
Offer a very short reply. -0.38. In the year 2008, what is the difference between the Rating (1=low 6=high) in Low & middle income and Rating (1=low 6=high) in Bolivia?
Provide a succinct answer. -0.57. In the year 2008, what is the difference between the Rating (1=low 6=high) of Low & middle income and Rating (1=low 6=high) of St. Lucia?
Keep it short and to the point. -0.57. In the year 2008, what is the difference between the Rating (1=low 6=high) of Bolivia and Rating (1=low 6=high) of St. Lucia?
Keep it short and to the point. 0. In the year 2009, what is the difference between the Rating (1=low 6=high) in Europe(developing only) and Rating (1=low 6=high) in Low & middle income?
Make the answer very short. 0.14. In the year 2009, what is the difference between the Rating (1=low 6=high) in Europe(developing only) and Rating (1=low 6=high) in Bolivia?
Ensure brevity in your answer.  -0.39. In the year 2009, what is the difference between the Rating (1=low 6=high) in Europe(developing only) and Rating (1=low 6=high) in St. Lucia?
Your response must be concise. -0.89. In the year 2009, what is the difference between the Rating (1=low 6=high) in Low & middle income and Rating (1=low 6=high) in Bolivia?
Offer a very short reply. -0.53. In the year 2009, what is the difference between the Rating (1=low 6=high) of Low & middle income and Rating (1=low 6=high) of St. Lucia?
Keep it short and to the point. -1.03. In the year 2010, what is the difference between the Rating (1=low 6=high) of Europe(developing only) and Rating (1=low 6=high) of Low & middle income?
Make the answer very short. 0.13. In the year 2010, what is the difference between the Rating (1=low 6=high) of Europe(developing only) and Rating (1=low 6=high) of Bolivia?
Provide a short and direct response. -0.39. In the year 2010, what is the difference between the Rating (1=low 6=high) in Europe(developing only) and Rating (1=low 6=high) in St. Lucia?
Your response must be concise. -0.89. In the year 2010, what is the difference between the Rating (1=low 6=high) of Low & middle income and Rating (1=low 6=high) of Bolivia?
Offer a very short reply. -0.52. In the year 2010, what is the difference between the Rating (1=low 6=high) of Low & middle income and Rating (1=low 6=high) of St. Lucia?
Your answer should be very brief. -1.02. In the year 2010, what is the difference between the Rating (1=low 6=high) in Bolivia and Rating (1=low 6=high) in St. Lucia?
Offer a terse response. -0.5. In the year 2011, what is the difference between the Rating (1=low 6=high) in Europe(developing only) and Rating (1=low 6=high) in Low & middle income?
Make the answer very short. 0.15. In the year 2011, what is the difference between the Rating (1=low 6=high) in Europe(developing only) and Rating (1=low 6=high) in Bolivia?
Your answer should be very brief. -0.38. In the year 2011, what is the difference between the Rating (1=low 6=high) in Europe(developing only) and Rating (1=low 6=high) in St. Lucia?
Provide a short and direct response. -0.88. In the year 2011, what is the difference between the Rating (1=low 6=high) of Low & middle income and Rating (1=low 6=high) of Bolivia?
Keep it short and to the point. -0.53. In the year 2011, what is the difference between the Rating (1=low 6=high) of Low & middle income and Rating (1=low 6=high) of St. Lucia?
Offer a very short reply. -1.03. In the year 2011, what is the difference between the Rating (1=low 6=high) of Bolivia and Rating (1=low 6=high) of St. Lucia?
Offer a very short reply. -0.5. In the year 2012, what is the difference between the Rating (1=low 6=high) in Europe(developing only) and Rating (1=low 6=high) in Low & middle income?
Give a very brief answer. 0.29. In the year 2012, what is the difference between the Rating (1=low 6=high) in Europe(developing only) and Rating (1=low 6=high) in St. Lucia?
Your answer should be compact. -0.75. In the year 2012, what is the difference between the Rating (1=low 6=high) of Low & middle income and Rating (1=low 6=high) of Bolivia?
Provide a succinct answer. -0.54. In the year 2012, what is the difference between the Rating (1=low 6=high) of Low & middle income and Rating (1=low 6=high) of St. Lucia?
Provide a succinct answer. -1.04. In the year 2012, what is the difference between the Rating (1=low 6=high) in Bolivia and Rating (1=low 6=high) in St. Lucia?
Make the answer very short. -0.5. What is the ratio of the Rating (1=low 6=high) in Low & middle income in 2005 to that in 2006?
Make the answer very short. 1.01. What is the ratio of the Rating (1=low 6=high) of St. Lucia in 2005 to that in 2006?
Keep it short and to the point. 1. What is the ratio of the Rating (1=low 6=high) in Europe(developing only) in 2005 to that in 2007?
Keep it short and to the point. 0.97. What is the ratio of the Rating (1=low 6=high) in Low & middle income in 2005 to that in 2007?
Ensure brevity in your answer.  1. What is the ratio of the Rating (1=low 6=high) of Bolivia in 2005 to that in 2007?
Your response must be concise. 1. What is the ratio of the Rating (1=low 6=high) in Europe(developing only) in 2005 to that in 2008?
Offer a very short reply. 0.95. What is the ratio of the Rating (1=low 6=high) in Europe(developing only) in 2005 to that in 2009?
Make the answer very short. 0.96. What is the ratio of the Rating (1=low 6=high) in Bolivia in 2005 to that in 2009?
Make the answer very short. 1. What is the ratio of the Rating (1=low 6=high) in St. Lucia in 2005 to that in 2009?
Your answer should be very brief. 0.78. What is the ratio of the Rating (1=low 6=high) of Europe(developing only) in 2005 to that in 2010?
Make the answer very short. 0.96. What is the ratio of the Rating (1=low 6=high) in Low & middle income in 2005 to that in 2010?
Offer a very short reply. 0.98. What is the ratio of the Rating (1=low 6=high) in Bolivia in 2005 to that in 2010?
Your response must be concise. 1. What is the ratio of the Rating (1=low 6=high) of Europe(developing only) in 2005 to that in 2011?
Your response must be concise. 0.95. What is the ratio of the Rating (1=low 6=high) of Low & middle income in 2005 to that in 2011?
Your answer should be compact. 0.99. What is the ratio of the Rating (1=low 6=high) of Bolivia in 2005 to that in 2011?
Keep it short and to the point. 1. What is the ratio of the Rating (1=low 6=high) in Low & middle income in 2005 to that in 2012?
Your answer should be compact. 0.99. What is the ratio of the Rating (1=low 6=high) of St. Lucia in 2005 to that in 2012?
Your answer should be very brief. 0.78. What is the ratio of the Rating (1=low 6=high) in Europe(developing only) in 2006 to that in 2007?
Provide a succinct answer. 1.01. What is the ratio of the Rating (1=low 6=high) of Bolivia in 2006 to that in 2007?
Keep it short and to the point. 1. What is the ratio of the Rating (1=low 6=high) in Europe(developing only) in 2006 to that in 2008?
Keep it short and to the point. 0.99. What is the ratio of the Rating (1=low 6=high) of Low & middle income in 2006 to that in 2008?
Your answer should be compact. 0.99. What is the ratio of the Rating (1=low 6=high) of Europe(developing only) in 2006 to that in 2009?
Offer a terse response. 1. What is the ratio of the Rating (1=low 6=high) of Low & middle income in 2006 to that in 2009?
Your answer should be compact. 0.98. What is the ratio of the Rating (1=low 6=high) in St. Lucia in 2006 to that in 2009?
Ensure brevity in your answer.  0.78. What is the ratio of the Rating (1=low 6=high) in Europe(developing only) in 2006 to that in 2010?
Offer a terse response. 1. What is the ratio of the Rating (1=low 6=high) in Low & middle income in 2006 to that in 2010?
Make the answer very short. 0.98. What is the ratio of the Rating (1=low 6=high) of Low & middle income in 2006 to that in 2011?
Provide a short and direct response. 0.98. What is the ratio of the Rating (1=low 6=high) of St. Lucia in 2006 to that in 2011?
Your answer should be compact. 0.78. What is the ratio of the Rating (1=low 6=high) in Low & middle income in 2006 to that in 2012?
Your response must be concise. 0.98. What is the ratio of the Rating (1=low 6=high) in Bolivia in 2006 to that in 2012?
Make the answer very short. 1. What is the ratio of the Rating (1=low 6=high) in Europe(developing only) in 2007 to that in 2008?
Keep it short and to the point. 0.98. What is the ratio of the Rating (1=low 6=high) of Low & middle income in 2007 to that in 2008?
Your response must be concise. 1. What is the ratio of the Rating (1=low 6=high) in Bolivia in 2007 to that in 2008?
Keep it short and to the point. 1. What is the ratio of the Rating (1=low 6=high) of Europe(developing only) in 2007 to that in 2009?
Offer a terse response. 0.99. What is the ratio of the Rating (1=low 6=high) in Low & middle income in 2007 to that in 2009?
Give a very brief answer. 0.98. What is the ratio of the Rating (1=low 6=high) in St. Lucia in 2007 to that in 2009?
Ensure brevity in your answer.  0.89. What is the ratio of the Rating (1=low 6=high) in Europe(developing only) in 2007 to that in 2010?
Offer a very short reply. 0.99. What is the ratio of the Rating (1=low 6=high) in Low & middle income in 2007 to that in 2010?
Make the answer very short. 0.98. What is the ratio of the Rating (1=low 6=high) of Europe(developing only) in 2007 to that in 2011?
Your answer should be compact. 0.98. What is the ratio of the Rating (1=low 6=high) in Low & middle income in 2007 to that in 2011?
Ensure brevity in your answer.  0.98. What is the ratio of the Rating (1=low 6=high) of Low & middle income in 2007 to that in 2012?
Make the answer very short. 0.99. What is the ratio of the Rating (1=low 6=high) in St. Lucia in 2007 to that in 2012?
Offer a terse response. 0.89. What is the ratio of the Rating (1=low 6=high) in Europe(developing only) in 2008 to that in 2009?
Offer a terse response. 1. What is the ratio of the Rating (1=low 6=high) of Bolivia in 2008 to that in 2009?
Offer a terse response. 1. What is the ratio of the Rating (1=low 6=high) of St. Lucia in 2008 to that in 2009?
Offer a terse response. 0.89. What is the ratio of the Rating (1=low 6=high) of Europe(developing only) in 2008 to that in 2010?
Provide a succinct answer. 1. What is the ratio of the Rating (1=low 6=high) in Low & middle income in 2008 to that in 2010?
Offer a terse response. 0.98. What is the ratio of the Rating (1=low 6=high) of Bolivia in 2008 to that in 2010?
Your answer should be very brief. 1. What is the ratio of the Rating (1=low 6=high) in Low & middle income in 2008 to that in 2011?
Make the answer very short. 0.99. What is the ratio of the Rating (1=low 6=high) in Bolivia in 2008 to that in 2011?
Offer a terse response. 1. What is the ratio of the Rating (1=low 6=high) of Europe(developing only) in 2008 to that in 2012?
Ensure brevity in your answer.  0.97. What is the ratio of the Rating (1=low 6=high) in Low & middle income in 2008 to that in 2012?
Offer a very short reply. 0.99. What is the ratio of the Rating (1=low 6=high) in Europe(developing only) in 2009 to that in 2010?
Offer a very short reply. 1. What is the ratio of the Rating (1=low 6=high) of Low & middle income in 2009 to that in 2010?
Give a very brief answer. 1. What is the ratio of the Rating (1=low 6=high) of Bolivia in 2009 to that in 2010?
Offer a terse response. 1. What is the ratio of the Rating (1=low 6=high) of Europe(developing only) in 2009 to that in 2011?
Give a very brief answer. 1. What is the ratio of the Rating (1=low 6=high) in Low & middle income in 2009 to that in 2011?
Give a very brief answer. 1. What is the ratio of the Rating (1=low 6=high) of Bolivia in 2009 to that in 2011?
Your answer should be compact. 1. What is the ratio of the Rating (1=low 6=high) in Europe(developing only) in 2009 to that in 2012?
Offer a terse response. 0.96. What is the ratio of the Rating (1=low 6=high) in Low & middle income in 2009 to that in 2012?
Offer a terse response. 1. What is the ratio of the Rating (1=low 6=high) in Bolivia in 2009 to that in 2012?
Keep it short and to the point. 1. What is the ratio of the Rating (1=low 6=high) in Europe(developing only) in 2010 to that in 2011?
Provide a succinct answer. 1. What is the ratio of the Rating (1=low 6=high) of Europe(developing only) in 2010 to that in 2012?
Offer a very short reply. 0.96. What is the ratio of the Rating (1=low 6=high) in Low & middle income in 2010 to that in 2012?
Ensure brevity in your answer.  1.01. What is the ratio of the Rating (1=low 6=high) of Europe(developing only) in 2011 to that in 2012?
Offer a very short reply. 0.97. What is the ratio of the Rating (1=low 6=high) of Low & middle income in 2011 to that in 2012?
Provide a short and direct response. 1. What is the difference between the highest and the second highest Rating (1=low 6=high) in Europe(developing only)?
Make the answer very short. 0.12. What is the difference between the highest and the second highest Rating (1=low 6=high) in Low & middle income?
Provide a succinct answer. 0.01. What is the difference between the highest and the second highest Rating (1=low 6=high) in St. Lucia?
Keep it short and to the point. 0. What is the difference between the highest and the lowest Rating (1=low 6=high) of Low & middle income?
Your answer should be compact. 0.08. What is the difference between the highest and the lowest Rating (1=low 6=high) of Bolivia?
Offer a terse response. 0. What is the difference between the highest and the lowest Rating (1=low 6=high) of St. Lucia?
Give a very brief answer. 1. 